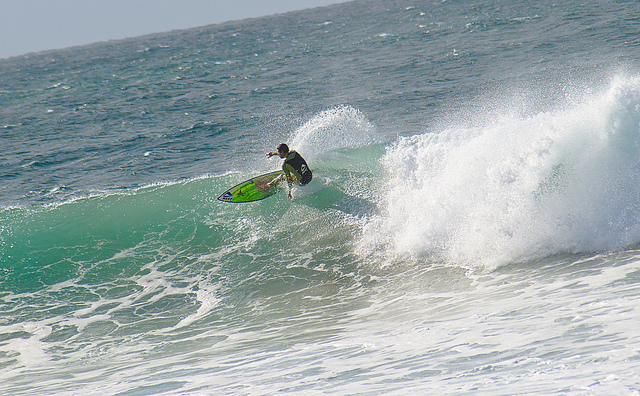What kind of surfboard is the person using? The person is using a shortboard, which is designed for quick turns and high performance on larger waves. Does it look like a good day for surfing? Absolutely, the waves are of a significant size and offer a great opportunity for experienced surfers to challenge themselves. 